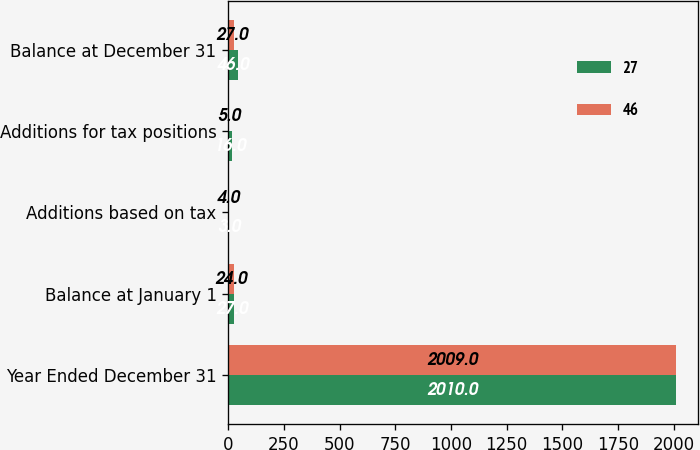Convert chart to OTSL. <chart><loc_0><loc_0><loc_500><loc_500><stacked_bar_chart><ecel><fcel>Year Ended December 31<fcel>Balance at January 1<fcel>Additions based on tax<fcel>Additions for tax positions<fcel>Balance at December 31<nl><fcel>27<fcel>2010<fcel>27<fcel>3<fcel>16<fcel>46<nl><fcel>46<fcel>2009<fcel>24<fcel>4<fcel>5<fcel>27<nl></chart> 